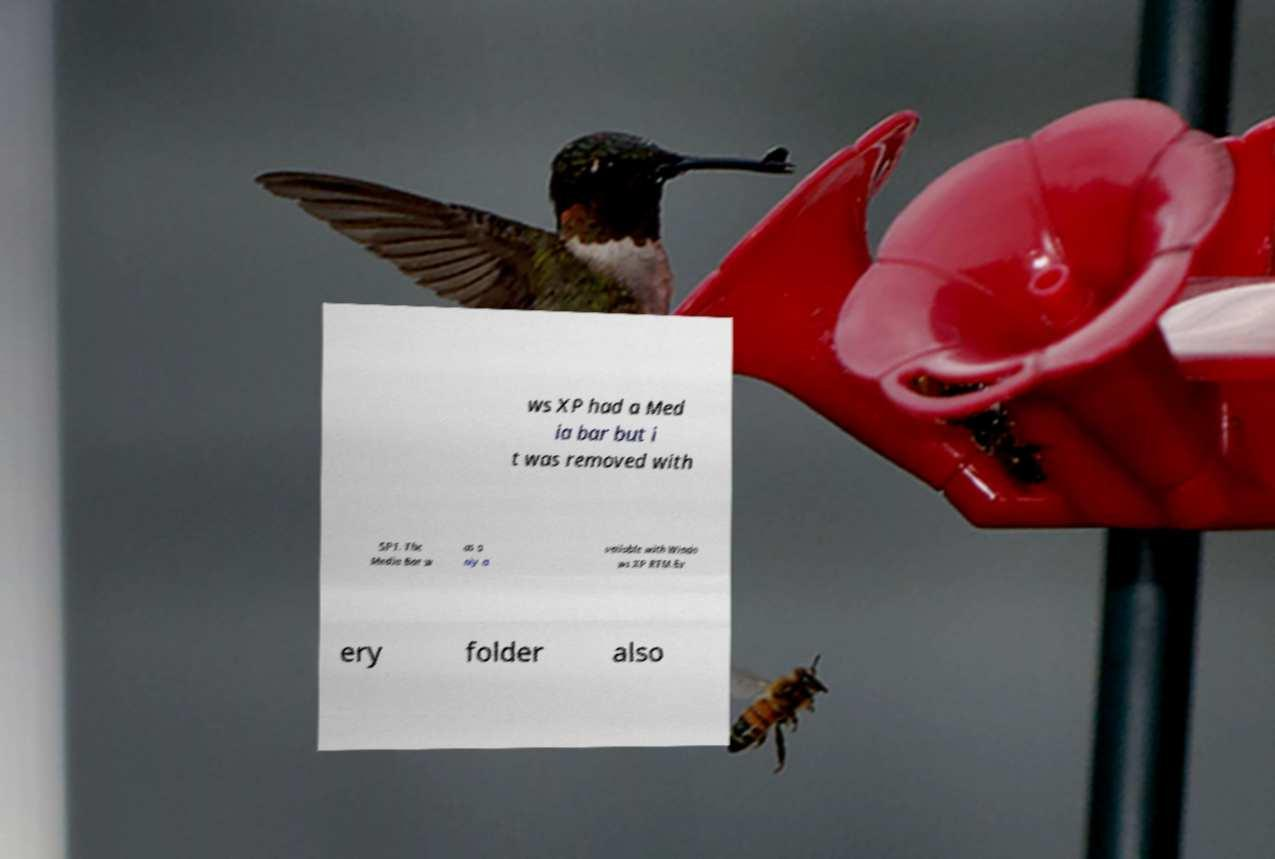Please read and relay the text visible in this image. What does it say? ws XP had a Med ia bar but i t was removed with SP1. The Media Bar w as o nly a vailable with Windo ws XP RTM.Ev ery folder also 